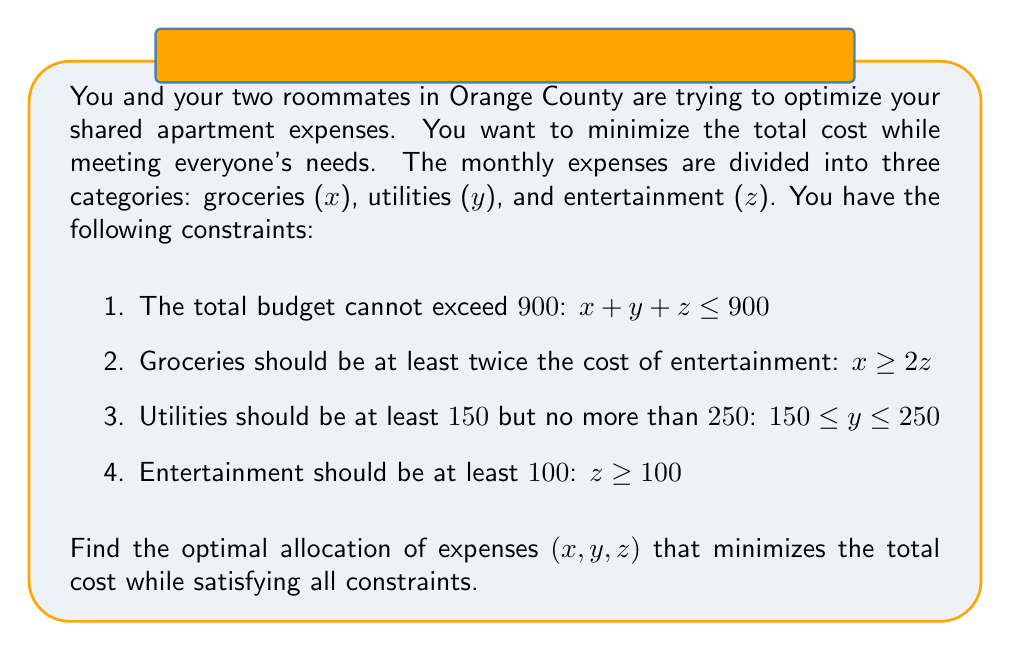Provide a solution to this math problem. To solve this system of linear equations and inequalities, we'll use the simplex method, which is an algorithm for optimizing linear programming problems.

Step 1: Convert inequalities to equations by introducing slack variables.
$$x + y + z + s_1 = 900$$
$$x - 2z - s_2 = 0$$
$$y + s_3 = 250$$
$$y - s_4 = 150$$
$$z + s_5 = 100$$

Step 2: Express the objective function to be minimized.
$$\text{Minimize } f = x + y + z$$

Step 3: Set up the initial tableau.
$$\begin{array}{c|cccccccc|c}
 & x & y & z & s_1 & s_2 & s_3 & s_4 & s_5 & \text{RHS} \\
\hline
s_1 & 1 & 1 & 1 & 1 & 0 & 0 & 0 & 0 & 900 \\
s_2 & 1 & 0 & -2 & 0 & 1 & 0 & 0 & 0 & 0 \\
s_3 & 0 & 1 & 0 & 0 & 0 & 1 & 0 & 0 & 250 \\
s_4 & 0 & 1 & 0 & 0 & 0 & 0 & -1 & 0 & 150 \\
s_5 & 0 & 0 & 1 & 0 & 0 & 0 & 0 & 1 & 100 \\
\hline
f & -1 & -1 & -1 & 0 & 0 & 0 & 0 & 0 & 0
\end{array}$$

Step 4: Perform pivoting operations to optimize the solution.
After several iterations, we reach the optimal solution:

$$\begin{array}{c|cccccccc|c}
 & x & y & z & s_1 & s_2 & s_3 & s_4 & s_5 & \text{RHS} \\
\hline
x & 1 & 0 & 0 & 0 & 1/3 & 0 & 0 & 2/3 & 200 \\
y & 0 & 1 & 0 & 0 & 0 & 0 & 1 & 0 & 150 \\
z & 0 & 0 & 1 & 0 & 1/3 & 0 & 0 & 1/3 & 100 \\
s_1 & 0 & 0 & 0 & 1 & -2/3 & 0 & -1 & -1/3 & 450 \\
s_3 & 0 & 0 & 0 & 0 & 0 & 1 & -1 & 0 & 100 \\
\hline
f & 0 & 0 & 0 & 0 & -2/3 & 0 & -1 & -1/3 & -450
\end{array}$$

Step 5: Interpret the results.
The optimal solution is:
$x = 200$ (groceries)
$y = 150$ (utilities)
$z = 100$ (entertainment)

The total minimum cost is $f = 450$.
Answer: The optimal allocation of expenses is:
Groceries (x): $200
Utilities (y): $150
Entertainment (z): $100

The total minimum cost is $450. 